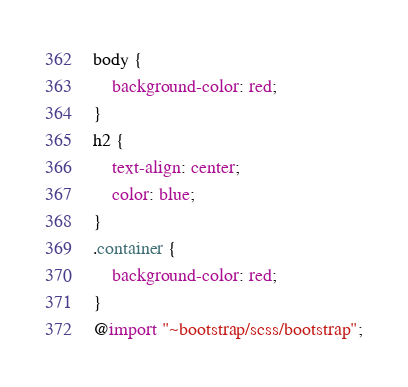Convert code to text. <code><loc_0><loc_0><loc_500><loc_500><_CSS_>body {
    background-color: red;
}
h2 {
    text-align: center;
    color: blue;
}
.container {
    background-color: red;
}
@import "~bootstrap/scss/bootstrap";
</code> 